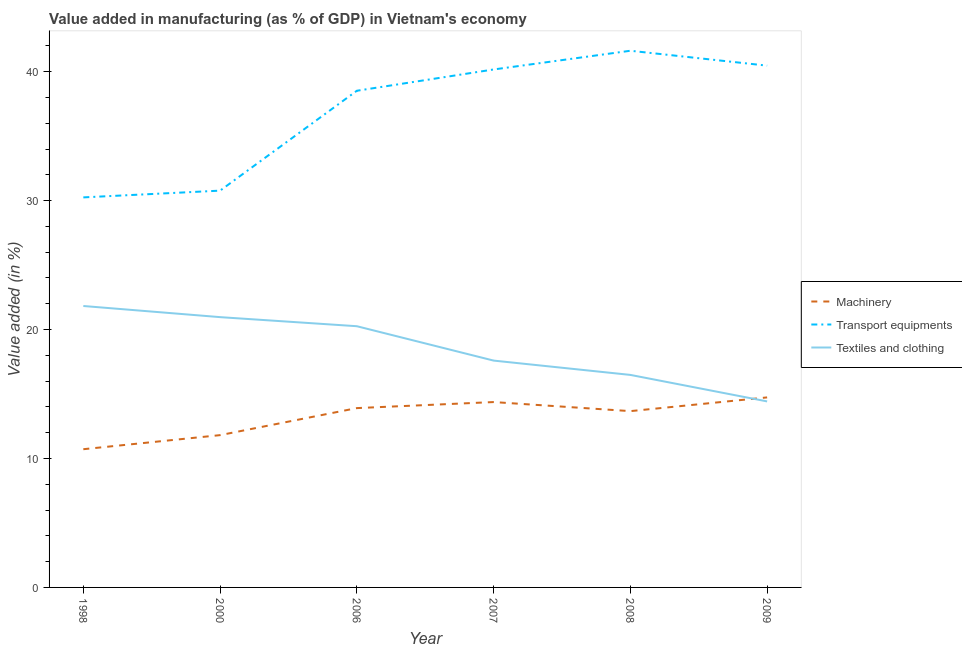How many different coloured lines are there?
Ensure brevity in your answer.  3. Is the number of lines equal to the number of legend labels?
Offer a very short reply. Yes. What is the value added in manufacturing textile and clothing in 2000?
Your answer should be very brief. 20.96. Across all years, what is the maximum value added in manufacturing textile and clothing?
Your answer should be very brief. 21.83. Across all years, what is the minimum value added in manufacturing transport equipments?
Give a very brief answer. 30.25. In which year was the value added in manufacturing machinery minimum?
Your answer should be compact. 1998. What is the total value added in manufacturing textile and clothing in the graph?
Offer a very short reply. 111.55. What is the difference between the value added in manufacturing transport equipments in 2006 and that in 2009?
Ensure brevity in your answer.  -1.95. What is the difference between the value added in manufacturing textile and clothing in 2006 and the value added in manufacturing transport equipments in 2009?
Your response must be concise. -20.21. What is the average value added in manufacturing machinery per year?
Ensure brevity in your answer.  13.2. In the year 2009, what is the difference between the value added in manufacturing machinery and value added in manufacturing transport equipments?
Offer a terse response. -25.73. What is the ratio of the value added in manufacturing transport equipments in 1998 to that in 2000?
Your answer should be very brief. 0.98. Is the value added in manufacturing textile and clothing in 1998 less than that in 2007?
Provide a succinct answer. No. Is the difference between the value added in manufacturing machinery in 2006 and 2008 greater than the difference between the value added in manufacturing textile and clothing in 2006 and 2008?
Make the answer very short. No. What is the difference between the highest and the second highest value added in manufacturing machinery?
Offer a terse response. 0.36. What is the difference between the highest and the lowest value added in manufacturing transport equipments?
Your answer should be compact. 11.37. In how many years, is the value added in manufacturing textile and clothing greater than the average value added in manufacturing textile and clothing taken over all years?
Ensure brevity in your answer.  3. Is the sum of the value added in manufacturing textile and clothing in 2008 and 2009 greater than the maximum value added in manufacturing transport equipments across all years?
Keep it short and to the point. No. Does the value added in manufacturing textile and clothing monotonically increase over the years?
Your answer should be compact. No. What is the difference between two consecutive major ticks on the Y-axis?
Your answer should be very brief. 10. Does the graph contain any zero values?
Your answer should be very brief. No. Does the graph contain grids?
Your answer should be very brief. No. How many legend labels are there?
Your answer should be compact. 3. What is the title of the graph?
Provide a succinct answer. Value added in manufacturing (as % of GDP) in Vietnam's economy. Does "Wage workers" appear as one of the legend labels in the graph?
Make the answer very short. No. What is the label or title of the Y-axis?
Provide a short and direct response. Value added (in %). What is the Value added (in %) in Machinery in 1998?
Make the answer very short. 10.72. What is the Value added (in %) in Transport equipments in 1998?
Your response must be concise. 30.25. What is the Value added (in %) of Textiles and clothing in 1998?
Provide a short and direct response. 21.83. What is the Value added (in %) in Machinery in 2000?
Keep it short and to the point. 11.81. What is the Value added (in %) of Transport equipments in 2000?
Your answer should be compact. 30.77. What is the Value added (in %) of Textiles and clothing in 2000?
Ensure brevity in your answer.  20.96. What is the Value added (in %) of Machinery in 2006?
Your answer should be very brief. 13.91. What is the Value added (in %) of Transport equipments in 2006?
Give a very brief answer. 38.52. What is the Value added (in %) of Textiles and clothing in 2006?
Offer a very short reply. 20.26. What is the Value added (in %) in Machinery in 2007?
Offer a very short reply. 14.38. What is the Value added (in %) in Transport equipments in 2007?
Offer a terse response. 40.17. What is the Value added (in %) of Textiles and clothing in 2007?
Ensure brevity in your answer.  17.59. What is the Value added (in %) of Machinery in 2008?
Your answer should be very brief. 13.67. What is the Value added (in %) in Transport equipments in 2008?
Give a very brief answer. 41.62. What is the Value added (in %) in Textiles and clothing in 2008?
Give a very brief answer. 16.48. What is the Value added (in %) of Machinery in 2009?
Give a very brief answer. 14.74. What is the Value added (in %) in Transport equipments in 2009?
Offer a very short reply. 40.47. What is the Value added (in %) in Textiles and clothing in 2009?
Ensure brevity in your answer.  14.43. Across all years, what is the maximum Value added (in %) of Machinery?
Your response must be concise. 14.74. Across all years, what is the maximum Value added (in %) of Transport equipments?
Your answer should be very brief. 41.62. Across all years, what is the maximum Value added (in %) of Textiles and clothing?
Offer a very short reply. 21.83. Across all years, what is the minimum Value added (in %) of Machinery?
Your answer should be very brief. 10.72. Across all years, what is the minimum Value added (in %) in Transport equipments?
Provide a short and direct response. 30.25. Across all years, what is the minimum Value added (in %) of Textiles and clothing?
Provide a succinct answer. 14.43. What is the total Value added (in %) in Machinery in the graph?
Give a very brief answer. 79.23. What is the total Value added (in %) in Transport equipments in the graph?
Ensure brevity in your answer.  221.81. What is the total Value added (in %) in Textiles and clothing in the graph?
Keep it short and to the point. 111.55. What is the difference between the Value added (in %) of Machinery in 1998 and that in 2000?
Provide a short and direct response. -1.09. What is the difference between the Value added (in %) of Transport equipments in 1998 and that in 2000?
Offer a very short reply. -0.52. What is the difference between the Value added (in %) in Textiles and clothing in 1998 and that in 2000?
Provide a succinct answer. 0.86. What is the difference between the Value added (in %) in Machinery in 1998 and that in 2006?
Your answer should be very brief. -3.19. What is the difference between the Value added (in %) in Transport equipments in 1998 and that in 2006?
Give a very brief answer. -8.27. What is the difference between the Value added (in %) of Textiles and clothing in 1998 and that in 2006?
Your answer should be compact. 1.57. What is the difference between the Value added (in %) in Machinery in 1998 and that in 2007?
Your answer should be very brief. -3.66. What is the difference between the Value added (in %) of Transport equipments in 1998 and that in 2007?
Keep it short and to the point. -9.92. What is the difference between the Value added (in %) of Textiles and clothing in 1998 and that in 2007?
Offer a very short reply. 4.23. What is the difference between the Value added (in %) of Machinery in 1998 and that in 2008?
Offer a very short reply. -2.95. What is the difference between the Value added (in %) in Transport equipments in 1998 and that in 2008?
Your response must be concise. -11.37. What is the difference between the Value added (in %) in Textiles and clothing in 1998 and that in 2008?
Your response must be concise. 5.34. What is the difference between the Value added (in %) of Machinery in 1998 and that in 2009?
Your response must be concise. -4.02. What is the difference between the Value added (in %) of Transport equipments in 1998 and that in 2009?
Give a very brief answer. -10.22. What is the difference between the Value added (in %) of Textiles and clothing in 1998 and that in 2009?
Give a very brief answer. 7.4. What is the difference between the Value added (in %) of Machinery in 2000 and that in 2006?
Keep it short and to the point. -2.1. What is the difference between the Value added (in %) in Transport equipments in 2000 and that in 2006?
Provide a short and direct response. -7.75. What is the difference between the Value added (in %) in Textiles and clothing in 2000 and that in 2006?
Ensure brevity in your answer.  0.7. What is the difference between the Value added (in %) of Machinery in 2000 and that in 2007?
Your answer should be very brief. -2.56. What is the difference between the Value added (in %) in Transport equipments in 2000 and that in 2007?
Your answer should be compact. -9.4. What is the difference between the Value added (in %) in Textiles and clothing in 2000 and that in 2007?
Offer a terse response. 3.37. What is the difference between the Value added (in %) in Machinery in 2000 and that in 2008?
Provide a succinct answer. -1.86. What is the difference between the Value added (in %) of Transport equipments in 2000 and that in 2008?
Provide a short and direct response. -10.85. What is the difference between the Value added (in %) of Textiles and clothing in 2000 and that in 2008?
Make the answer very short. 4.48. What is the difference between the Value added (in %) in Machinery in 2000 and that in 2009?
Give a very brief answer. -2.93. What is the difference between the Value added (in %) in Transport equipments in 2000 and that in 2009?
Provide a succinct answer. -9.69. What is the difference between the Value added (in %) in Textiles and clothing in 2000 and that in 2009?
Make the answer very short. 6.54. What is the difference between the Value added (in %) of Machinery in 2006 and that in 2007?
Your response must be concise. -0.47. What is the difference between the Value added (in %) in Transport equipments in 2006 and that in 2007?
Make the answer very short. -1.65. What is the difference between the Value added (in %) of Textiles and clothing in 2006 and that in 2007?
Your response must be concise. 2.67. What is the difference between the Value added (in %) in Machinery in 2006 and that in 2008?
Your answer should be very brief. 0.23. What is the difference between the Value added (in %) of Transport equipments in 2006 and that in 2008?
Your answer should be compact. -3.1. What is the difference between the Value added (in %) of Textiles and clothing in 2006 and that in 2008?
Make the answer very short. 3.78. What is the difference between the Value added (in %) of Machinery in 2006 and that in 2009?
Your response must be concise. -0.83. What is the difference between the Value added (in %) of Transport equipments in 2006 and that in 2009?
Ensure brevity in your answer.  -1.95. What is the difference between the Value added (in %) of Textiles and clothing in 2006 and that in 2009?
Provide a succinct answer. 5.83. What is the difference between the Value added (in %) of Machinery in 2007 and that in 2008?
Give a very brief answer. 0.7. What is the difference between the Value added (in %) in Transport equipments in 2007 and that in 2008?
Give a very brief answer. -1.45. What is the difference between the Value added (in %) of Textiles and clothing in 2007 and that in 2008?
Make the answer very short. 1.11. What is the difference between the Value added (in %) of Machinery in 2007 and that in 2009?
Offer a terse response. -0.36. What is the difference between the Value added (in %) of Transport equipments in 2007 and that in 2009?
Offer a very short reply. -0.3. What is the difference between the Value added (in %) of Textiles and clothing in 2007 and that in 2009?
Keep it short and to the point. 3.17. What is the difference between the Value added (in %) of Machinery in 2008 and that in 2009?
Your answer should be very brief. -1.06. What is the difference between the Value added (in %) in Transport equipments in 2008 and that in 2009?
Provide a short and direct response. 1.16. What is the difference between the Value added (in %) of Textiles and clothing in 2008 and that in 2009?
Your answer should be compact. 2.06. What is the difference between the Value added (in %) in Machinery in 1998 and the Value added (in %) in Transport equipments in 2000?
Make the answer very short. -20.05. What is the difference between the Value added (in %) of Machinery in 1998 and the Value added (in %) of Textiles and clothing in 2000?
Offer a terse response. -10.24. What is the difference between the Value added (in %) in Transport equipments in 1998 and the Value added (in %) in Textiles and clothing in 2000?
Your answer should be very brief. 9.29. What is the difference between the Value added (in %) of Machinery in 1998 and the Value added (in %) of Transport equipments in 2006?
Offer a terse response. -27.8. What is the difference between the Value added (in %) of Machinery in 1998 and the Value added (in %) of Textiles and clothing in 2006?
Offer a very short reply. -9.54. What is the difference between the Value added (in %) in Transport equipments in 1998 and the Value added (in %) in Textiles and clothing in 2006?
Provide a succinct answer. 9.99. What is the difference between the Value added (in %) in Machinery in 1998 and the Value added (in %) in Transport equipments in 2007?
Your answer should be compact. -29.45. What is the difference between the Value added (in %) in Machinery in 1998 and the Value added (in %) in Textiles and clothing in 2007?
Provide a succinct answer. -6.87. What is the difference between the Value added (in %) of Transport equipments in 1998 and the Value added (in %) of Textiles and clothing in 2007?
Your answer should be compact. 12.66. What is the difference between the Value added (in %) of Machinery in 1998 and the Value added (in %) of Transport equipments in 2008?
Your answer should be compact. -30.9. What is the difference between the Value added (in %) of Machinery in 1998 and the Value added (in %) of Textiles and clothing in 2008?
Make the answer very short. -5.76. What is the difference between the Value added (in %) of Transport equipments in 1998 and the Value added (in %) of Textiles and clothing in 2008?
Give a very brief answer. 13.77. What is the difference between the Value added (in %) of Machinery in 1998 and the Value added (in %) of Transport equipments in 2009?
Your response must be concise. -29.75. What is the difference between the Value added (in %) of Machinery in 1998 and the Value added (in %) of Textiles and clothing in 2009?
Offer a terse response. -3.71. What is the difference between the Value added (in %) in Transport equipments in 1998 and the Value added (in %) in Textiles and clothing in 2009?
Give a very brief answer. 15.82. What is the difference between the Value added (in %) in Machinery in 2000 and the Value added (in %) in Transport equipments in 2006?
Keep it short and to the point. -26.71. What is the difference between the Value added (in %) in Machinery in 2000 and the Value added (in %) in Textiles and clothing in 2006?
Provide a short and direct response. -8.45. What is the difference between the Value added (in %) of Transport equipments in 2000 and the Value added (in %) of Textiles and clothing in 2006?
Make the answer very short. 10.52. What is the difference between the Value added (in %) of Machinery in 2000 and the Value added (in %) of Transport equipments in 2007?
Offer a terse response. -28.36. What is the difference between the Value added (in %) in Machinery in 2000 and the Value added (in %) in Textiles and clothing in 2007?
Provide a short and direct response. -5.78. What is the difference between the Value added (in %) in Transport equipments in 2000 and the Value added (in %) in Textiles and clothing in 2007?
Your answer should be very brief. 13.18. What is the difference between the Value added (in %) of Machinery in 2000 and the Value added (in %) of Transport equipments in 2008?
Your response must be concise. -29.81. What is the difference between the Value added (in %) of Machinery in 2000 and the Value added (in %) of Textiles and clothing in 2008?
Offer a terse response. -4.67. What is the difference between the Value added (in %) of Transport equipments in 2000 and the Value added (in %) of Textiles and clothing in 2008?
Offer a terse response. 14.29. What is the difference between the Value added (in %) of Machinery in 2000 and the Value added (in %) of Transport equipments in 2009?
Make the answer very short. -28.66. What is the difference between the Value added (in %) of Machinery in 2000 and the Value added (in %) of Textiles and clothing in 2009?
Your response must be concise. -2.62. What is the difference between the Value added (in %) of Transport equipments in 2000 and the Value added (in %) of Textiles and clothing in 2009?
Provide a short and direct response. 16.35. What is the difference between the Value added (in %) in Machinery in 2006 and the Value added (in %) in Transport equipments in 2007?
Provide a short and direct response. -26.26. What is the difference between the Value added (in %) of Machinery in 2006 and the Value added (in %) of Textiles and clothing in 2007?
Provide a short and direct response. -3.69. What is the difference between the Value added (in %) of Transport equipments in 2006 and the Value added (in %) of Textiles and clothing in 2007?
Your answer should be compact. 20.93. What is the difference between the Value added (in %) of Machinery in 2006 and the Value added (in %) of Transport equipments in 2008?
Ensure brevity in your answer.  -27.72. What is the difference between the Value added (in %) of Machinery in 2006 and the Value added (in %) of Textiles and clothing in 2008?
Keep it short and to the point. -2.57. What is the difference between the Value added (in %) of Transport equipments in 2006 and the Value added (in %) of Textiles and clothing in 2008?
Keep it short and to the point. 22.04. What is the difference between the Value added (in %) of Machinery in 2006 and the Value added (in %) of Transport equipments in 2009?
Provide a succinct answer. -26.56. What is the difference between the Value added (in %) of Machinery in 2006 and the Value added (in %) of Textiles and clothing in 2009?
Your answer should be compact. -0.52. What is the difference between the Value added (in %) of Transport equipments in 2006 and the Value added (in %) of Textiles and clothing in 2009?
Provide a succinct answer. 24.09. What is the difference between the Value added (in %) in Machinery in 2007 and the Value added (in %) in Transport equipments in 2008?
Offer a terse response. -27.25. What is the difference between the Value added (in %) of Machinery in 2007 and the Value added (in %) of Textiles and clothing in 2008?
Give a very brief answer. -2.11. What is the difference between the Value added (in %) in Transport equipments in 2007 and the Value added (in %) in Textiles and clothing in 2008?
Your response must be concise. 23.69. What is the difference between the Value added (in %) of Machinery in 2007 and the Value added (in %) of Transport equipments in 2009?
Provide a succinct answer. -26.09. What is the difference between the Value added (in %) of Machinery in 2007 and the Value added (in %) of Textiles and clothing in 2009?
Provide a short and direct response. -0.05. What is the difference between the Value added (in %) of Transport equipments in 2007 and the Value added (in %) of Textiles and clothing in 2009?
Offer a terse response. 25.74. What is the difference between the Value added (in %) in Machinery in 2008 and the Value added (in %) in Transport equipments in 2009?
Offer a terse response. -26.79. What is the difference between the Value added (in %) of Machinery in 2008 and the Value added (in %) of Textiles and clothing in 2009?
Make the answer very short. -0.75. What is the difference between the Value added (in %) in Transport equipments in 2008 and the Value added (in %) in Textiles and clothing in 2009?
Your answer should be compact. 27.2. What is the average Value added (in %) of Machinery per year?
Keep it short and to the point. 13.2. What is the average Value added (in %) in Transport equipments per year?
Provide a succinct answer. 36.97. What is the average Value added (in %) in Textiles and clothing per year?
Keep it short and to the point. 18.59. In the year 1998, what is the difference between the Value added (in %) of Machinery and Value added (in %) of Transport equipments?
Offer a terse response. -19.53. In the year 1998, what is the difference between the Value added (in %) of Machinery and Value added (in %) of Textiles and clothing?
Your answer should be compact. -11.11. In the year 1998, what is the difference between the Value added (in %) in Transport equipments and Value added (in %) in Textiles and clothing?
Keep it short and to the point. 8.42. In the year 2000, what is the difference between the Value added (in %) of Machinery and Value added (in %) of Transport equipments?
Your response must be concise. -18.96. In the year 2000, what is the difference between the Value added (in %) of Machinery and Value added (in %) of Textiles and clothing?
Provide a succinct answer. -9.15. In the year 2000, what is the difference between the Value added (in %) of Transport equipments and Value added (in %) of Textiles and clothing?
Provide a short and direct response. 9.81. In the year 2006, what is the difference between the Value added (in %) of Machinery and Value added (in %) of Transport equipments?
Your answer should be very brief. -24.61. In the year 2006, what is the difference between the Value added (in %) of Machinery and Value added (in %) of Textiles and clothing?
Offer a terse response. -6.35. In the year 2006, what is the difference between the Value added (in %) in Transport equipments and Value added (in %) in Textiles and clothing?
Provide a short and direct response. 18.26. In the year 2007, what is the difference between the Value added (in %) in Machinery and Value added (in %) in Transport equipments?
Offer a very short reply. -25.79. In the year 2007, what is the difference between the Value added (in %) of Machinery and Value added (in %) of Textiles and clothing?
Offer a very short reply. -3.22. In the year 2007, what is the difference between the Value added (in %) in Transport equipments and Value added (in %) in Textiles and clothing?
Your answer should be compact. 22.58. In the year 2008, what is the difference between the Value added (in %) in Machinery and Value added (in %) in Transport equipments?
Give a very brief answer. -27.95. In the year 2008, what is the difference between the Value added (in %) in Machinery and Value added (in %) in Textiles and clothing?
Your response must be concise. -2.81. In the year 2008, what is the difference between the Value added (in %) of Transport equipments and Value added (in %) of Textiles and clothing?
Your response must be concise. 25.14. In the year 2009, what is the difference between the Value added (in %) in Machinery and Value added (in %) in Transport equipments?
Ensure brevity in your answer.  -25.73. In the year 2009, what is the difference between the Value added (in %) in Machinery and Value added (in %) in Textiles and clothing?
Ensure brevity in your answer.  0.31. In the year 2009, what is the difference between the Value added (in %) of Transport equipments and Value added (in %) of Textiles and clothing?
Your answer should be very brief. 26.04. What is the ratio of the Value added (in %) in Machinery in 1998 to that in 2000?
Provide a short and direct response. 0.91. What is the ratio of the Value added (in %) of Transport equipments in 1998 to that in 2000?
Your answer should be very brief. 0.98. What is the ratio of the Value added (in %) in Textiles and clothing in 1998 to that in 2000?
Your answer should be compact. 1.04. What is the ratio of the Value added (in %) of Machinery in 1998 to that in 2006?
Your response must be concise. 0.77. What is the ratio of the Value added (in %) of Transport equipments in 1998 to that in 2006?
Provide a succinct answer. 0.79. What is the ratio of the Value added (in %) in Textiles and clothing in 1998 to that in 2006?
Ensure brevity in your answer.  1.08. What is the ratio of the Value added (in %) in Machinery in 1998 to that in 2007?
Ensure brevity in your answer.  0.75. What is the ratio of the Value added (in %) of Transport equipments in 1998 to that in 2007?
Ensure brevity in your answer.  0.75. What is the ratio of the Value added (in %) in Textiles and clothing in 1998 to that in 2007?
Keep it short and to the point. 1.24. What is the ratio of the Value added (in %) of Machinery in 1998 to that in 2008?
Your answer should be very brief. 0.78. What is the ratio of the Value added (in %) of Transport equipments in 1998 to that in 2008?
Your answer should be very brief. 0.73. What is the ratio of the Value added (in %) in Textiles and clothing in 1998 to that in 2008?
Give a very brief answer. 1.32. What is the ratio of the Value added (in %) in Machinery in 1998 to that in 2009?
Keep it short and to the point. 0.73. What is the ratio of the Value added (in %) in Transport equipments in 1998 to that in 2009?
Your answer should be very brief. 0.75. What is the ratio of the Value added (in %) in Textiles and clothing in 1998 to that in 2009?
Offer a very short reply. 1.51. What is the ratio of the Value added (in %) of Machinery in 2000 to that in 2006?
Provide a short and direct response. 0.85. What is the ratio of the Value added (in %) of Transport equipments in 2000 to that in 2006?
Offer a terse response. 0.8. What is the ratio of the Value added (in %) of Textiles and clothing in 2000 to that in 2006?
Make the answer very short. 1.03. What is the ratio of the Value added (in %) of Machinery in 2000 to that in 2007?
Give a very brief answer. 0.82. What is the ratio of the Value added (in %) in Transport equipments in 2000 to that in 2007?
Make the answer very short. 0.77. What is the ratio of the Value added (in %) in Textiles and clothing in 2000 to that in 2007?
Make the answer very short. 1.19. What is the ratio of the Value added (in %) of Machinery in 2000 to that in 2008?
Ensure brevity in your answer.  0.86. What is the ratio of the Value added (in %) of Transport equipments in 2000 to that in 2008?
Your answer should be very brief. 0.74. What is the ratio of the Value added (in %) in Textiles and clothing in 2000 to that in 2008?
Provide a succinct answer. 1.27. What is the ratio of the Value added (in %) in Machinery in 2000 to that in 2009?
Keep it short and to the point. 0.8. What is the ratio of the Value added (in %) of Transport equipments in 2000 to that in 2009?
Your response must be concise. 0.76. What is the ratio of the Value added (in %) in Textiles and clothing in 2000 to that in 2009?
Offer a very short reply. 1.45. What is the ratio of the Value added (in %) in Machinery in 2006 to that in 2007?
Your answer should be very brief. 0.97. What is the ratio of the Value added (in %) in Transport equipments in 2006 to that in 2007?
Offer a very short reply. 0.96. What is the ratio of the Value added (in %) in Textiles and clothing in 2006 to that in 2007?
Offer a very short reply. 1.15. What is the ratio of the Value added (in %) of Machinery in 2006 to that in 2008?
Ensure brevity in your answer.  1.02. What is the ratio of the Value added (in %) in Transport equipments in 2006 to that in 2008?
Ensure brevity in your answer.  0.93. What is the ratio of the Value added (in %) of Textiles and clothing in 2006 to that in 2008?
Offer a very short reply. 1.23. What is the ratio of the Value added (in %) of Machinery in 2006 to that in 2009?
Provide a short and direct response. 0.94. What is the ratio of the Value added (in %) in Transport equipments in 2006 to that in 2009?
Your response must be concise. 0.95. What is the ratio of the Value added (in %) of Textiles and clothing in 2006 to that in 2009?
Make the answer very short. 1.4. What is the ratio of the Value added (in %) of Machinery in 2007 to that in 2008?
Provide a short and direct response. 1.05. What is the ratio of the Value added (in %) in Transport equipments in 2007 to that in 2008?
Your response must be concise. 0.97. What is the ratio of the Value added (in %) in Textiles and clothing in 2007 to that in 2008?
Offer a terse response. 1.07. What is the ratio of the Value added (in %) in Machinery in 2007 to that in 2009?
Ensure brevity in your answer.  0.98. What is the ratio of the Value added (in %) in Textiles and clothing in 2007 to that in 2009?
Your answer should be very brief. 1.22. What is the ratio of the Value added (in %) in Machinery in 2008 to that in 2009?
Provide a short and direct response. 0.93. What is the ratio of the Value added (in %) of Transport equipments in 2008 to that in 2009?
Your answer should be very brief. 1.03. What is the ratio of the Value added (in %) in Textiles and clothing in 2008 to that in 2009?
Offer a very short reply. 1.14. What is the difference between the highest and the second highest Value added (in %) in Machinery?
Keep it short and to the point. 0.36. What is the difference between the highest and the second highest Value added (in %) of Transport equipments?
Your response must be concise. 1.16. What is the difference between the highest and the second highest Value added (in %) of Textiles and clothing?
Ensure brevity in your answer.  0.86. What is the difference between the highest and the lowest Value added (in %) of Machinery?
Offer a very short reply. 4.02. What is the difference between the highest and the lowest Value added (in %) in Transport equipments?
Make the answer very short. 11.37. What is the difference between the highest and the lowest Value added (in %) of Textiles and clothing?
Your response must be concise. 7.4. 